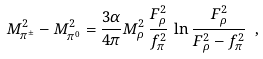Convert formula to latex. <formula><loc_0><loc_0><loc_500><loc_500>M ^ { 2 } _ { \pi ^ { \pm } } - M ^ { 2 } _ { \pi ^ { 0 } } = \frac { 3 \alpha } { 4 \pi } M ^ { 2 } _ { \rho } \, \frac { F _ { \rho } ^ { 2 } } { f ^ { 2 } _ { \pi } } \, \ln { \frac { F ^ { 2 } _ { \rho } } { F ^ { 2 } _ { \rho } - f ^ { 2 } _ { \pi } } } \ ,</formula> 